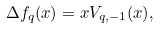Convert formula to latex. <formula><loc_0><loc_0><loc_500><loc_500>\Delta f _ { q } ( x ) = x V _ { q , - 1 } ( x ) ,</formula> 